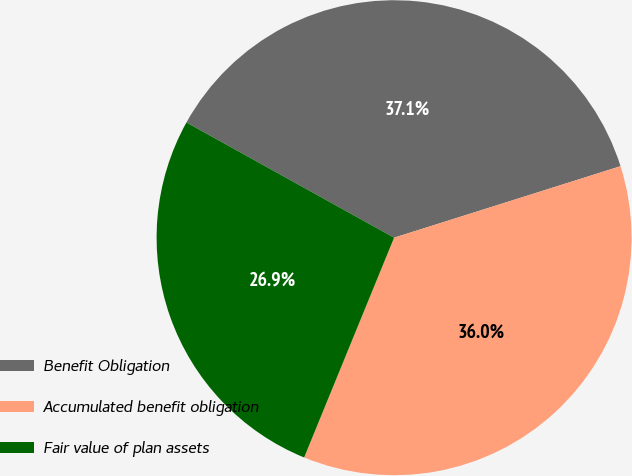<chart> <loc_0><loc_0><loc_500><loc_500><pie_chart><fcel>Benefit Obligation<fcel>Accumulated benefit obligation<fcel>Fair value of plan assets<nl><fcel>37.07%<fcel>36.05%<fcel>26.88%<nl></chart> 